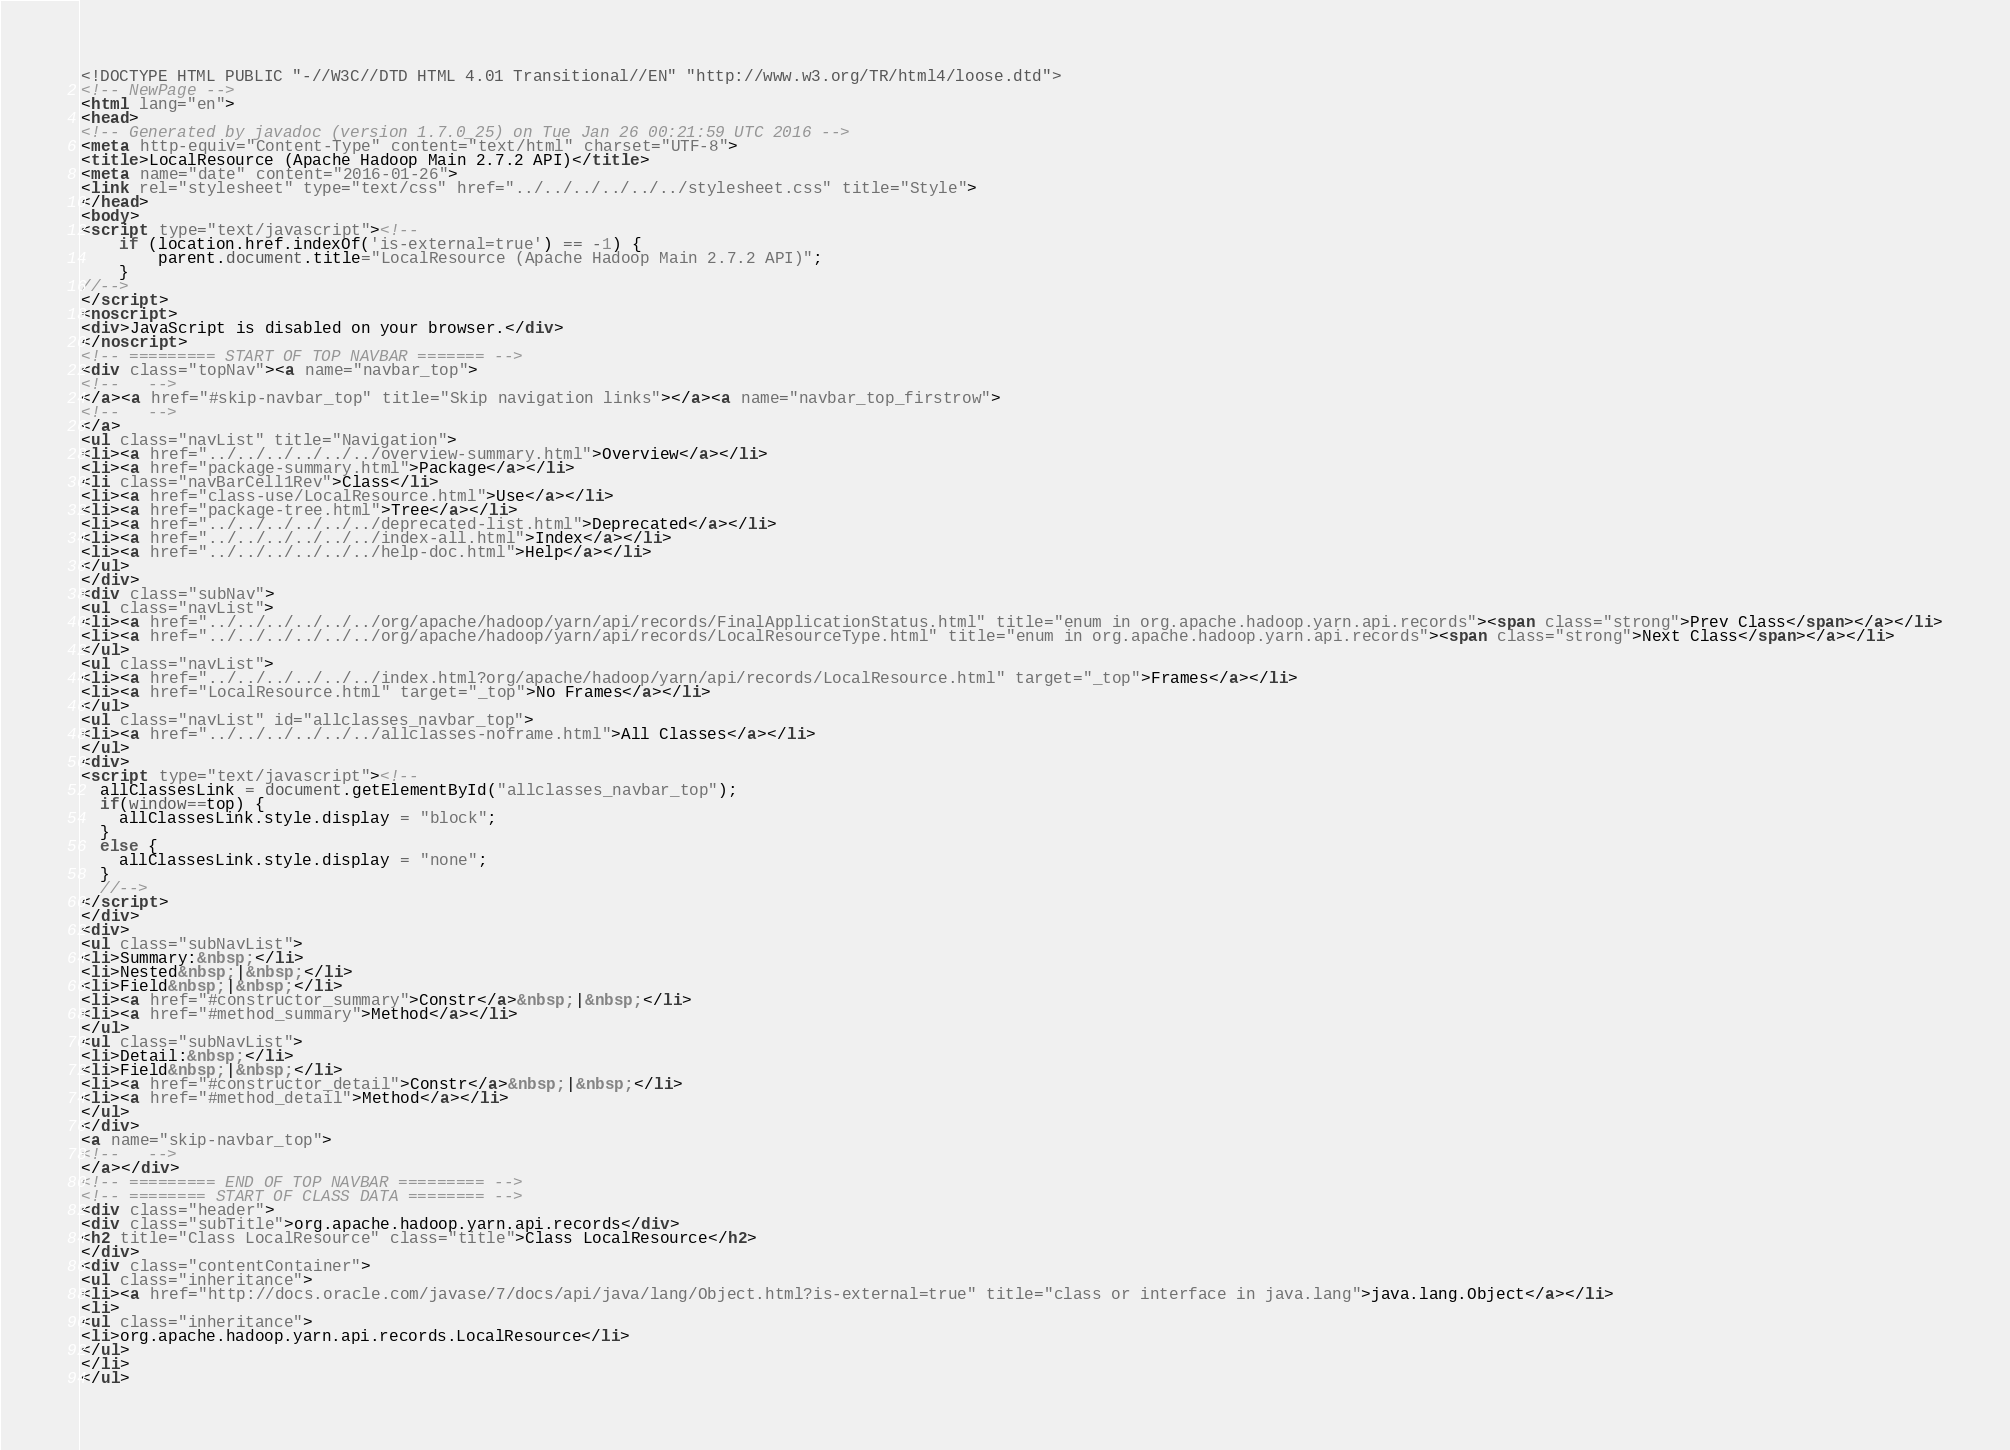Convert code to text. <code><loc_0><loc_0><loc_500><loc_500><_HTML_><!DOCTYPE HTML PUBLIC "-//W3C//DTD HTML 4.01 Transitional//EN" "http://www.w3.org/TR/html4/loose.dtd">
<!-- NewPage -->
<html lang="en">
<head>
<!-- Generated by javadoc (version 1.7.0_25) on Tue Jan 26 00:21:59 UTC 2016 -->
<meta http-equiv="Content-Type" content="text/html" charset="UTF-8">
<title>LocalResource (Apache Hadoop Main 2.7.2 API)</title>
<meta name="date" content="2016-01-26">
<link rel="stylesheet" type="text/css" href="../../../../../../stylesheet.css" title="Style">
</head>
<body>
<script type="text/javascript"><!--
    if (location.href.indexOf('is-external=true') == -1) {
        parent.document.title="LocalResource (Apache Hadoop Main 2.7.2 API)";
    }
//-->
</script>
<noscript>
<div>JavaScript is disabled on your browser.</div>
</noscript>
<!-- ========= START OF TOP NAVBAR ======= -->
<div class="topNav"><a name="navbar_top">
<!--   -->
</a><a href="#skip-navbar_top" title="Skip navigation links"></a><a name="navbar_top_firstrow">
<!--   -->
</a>
<ul class="navList" title="Navigation">
<li><a href="../../../../../../overview-summary.html">Overview</a></li>
<li><a href="package-summary.html">Package</a></li>
<li class="navBarCell1Rev">Class</li>
<li><a href="class-use/LocalResource.html">Use</a></li>
<li><a href="package-tree.html">Tree</a></li>
<li><a href="../../../../../../deprecated-list.html">Deprecated</a></li>
<li><a href="../../../../../../index-all.html">Index</a></li>
<li><a href="../../../../../../help-doc.html">Help</a></li>
</ul>
</div>
<div class="subNav">
<ul class="navList">
<li><a href="../../../../../../org/apache/hadoop/yarn/api/records/FinalApplicationStatus.html" title="enum in org.apache.hadoop.yarn.api.records"><span class="strong">Prev Class</span></a></li>
<li><a href="../../../../../../org/apache/hadoop/yarn/api/records/LocalResourceType.html" title="enum in org.apache.hadoop.yarn.api.records"><span class="strong">Next Class</span></a></li>
</ul>
<ul class="navList">
<li><a href="../../../../../../index.html?org/apache/hadoop/yarn/api/records/LocalResource.html" target="_top">Frames</a></li>
<li><a href="LocalResource.html" target="_top">No Frames</a></li>
</ul>
<ul class="navList" id="allclasses_navbar_top">
<li><a href="../../../../../../allclasses-noframe.html">All Classes</a></li>
</ul>
<div>
<script type="text/javascript"><!--
  allClassesLink = document.getElementById("allclasses_navbar_top");
  if(window==top) {
    allClassesLink.style.display = "block";
  }
  else {
    allClassesLink.style.display = "none";
  }
  //-->
</script>
</div>
<div>
<ul class="subNavList">
<li>Summary:&nbsp;</li>
<li>Nested&nbsp;|&nbsp;</li>
<li>Field&nbsp;|&nbsp;</li>
<li><a href="#constructor_summary">Constr</a>&nbsp;|&nbsp;</li>
<li><a href="#method_summary">Method</a></li>
</ul>
<ul class="subNavList">
<li>Detail:&nbsp;</li>
<li>Field&nbsp;|&nbsp;</li>
<li><a href="#constructor_detail">Constr</a>&nbsp;|&nbsp;</li>
<li><a href="#method_detail">Method</a></li>
</ul>
</div>
<a name="skip-navbar_top">
<!--   -->
</a></div>
<!-- ========= END OF TOP NAVBAR ========= -->
<!-- ======== START OF CLASS DATA ======== -->
<div class="header">
<div class="subTitle">org.apache.hadoop.yarn.api.records</div>
<h2 title="Class LocalResource" class="title">Class LocalResource</h2>
</div>
<div class="contentContainer">
<ul class="inheritance">
<li><a href="http://docs.oracle.com/javase/7/docs/api/java/lang/Object.html?is-external=true" title="class or interface in java.lang">java.lang.Object</a></li>
<li>
<ul class="inheritance">
<li>org.apache.hadoop.yarn.api.records.LocalResource</li>
</ul>
</li>
</ul></code> 